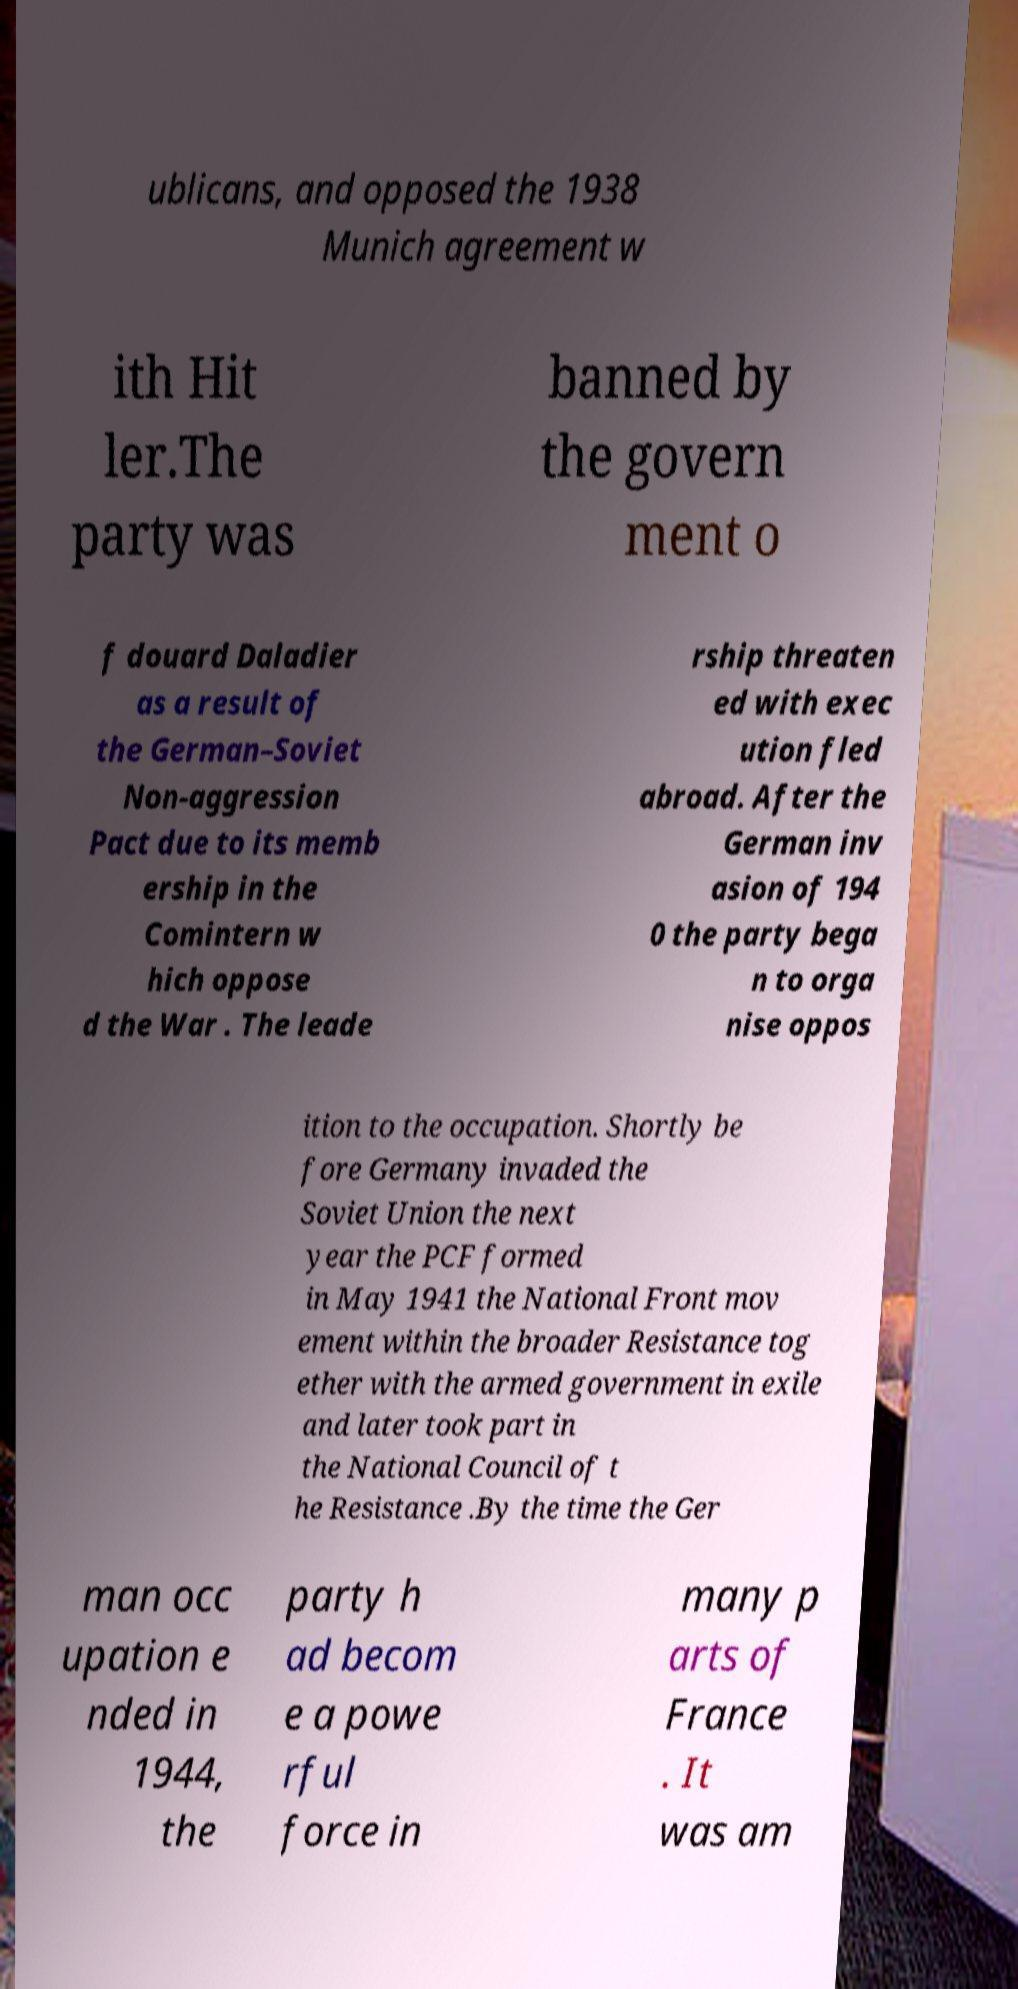What messages or text are displayed in this image? I need them in a readable, typed format. ublicans, and opposed the 1938 Munich agreement w ith Hit ler.The party was banned by the govern ment o f douard Daladier as a result of the German–Soviet Non-aggression Pact due to its memb ership in the Comintern w hich oppose d the War . The leade rship threaten ed with exec ution fled abroad. After the German inv asion of 194 0 the party bega n to orga nise oppos ition to the occupation. Shortly be fore Germany invaded the Soviet Union the next year the PCF formed in May 1941 the National Front mov ement within the broader Resistance tog ether with the armed government in exile and later took part in the National Council of t he Resistance .By the time the Ger man occ upation e nded in 1944, the party h ad becom e a powe rful force in many p arts of France . It was am 